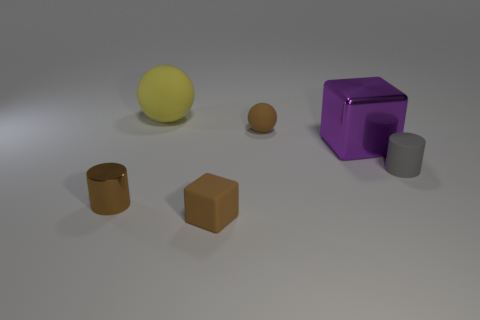There is a cylinder that is the same color as the small rubber cube; what material is it?
Keep it short and to the point. Metal. The brown thing that is both behind the small block and on the right side of the big sphere has what shape?
Your response must be concise. Sphere. There is a block that is on the left side of the sphere in front of the large object on the left side of the large shiny block; what is its material?
Your answer should be compact. Rubber. There is a metal object that is the same color as the tiny cube; what is its size?
Ensure brevity in your answer.  Small. What is the material of the yellow ball?
Keep it short and to the point. Rubber. Is the purple thing made of the same material as the brown object that is behind the big metal block?
Ensure brevity in your answer.  No. What color is the rubber thing in front of the brown object that is left of the large yellow matte sphere?
Your response must be concise. Brown. There is a brown thing that is both in front of the purple thing and to the right of the large yellow matte sphere; how big is it?
Make the answer very short. Small. How many other things are the same shape as the yellow matte object?
Provide a succinct answer. 1. Does the yellow object have the same shape as the metallic object behind the small gray object?
Offer a very short reply. No. 